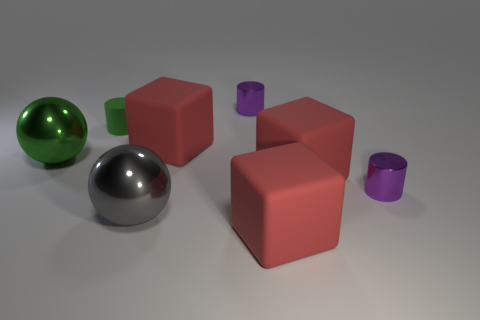Are the green cylinder and the purple cylinder behind the small green cylinder made of the same material?
Provide a short and direct response. No. The small matte thing is what color?
Provide a succinct answer. Green. What is the size of the green ball that is made of the same material as the gray ball?
Provide a short and direct response. Large. There is a big thing behind the green metallic object on the left side of the rubber cylinder; what number of red blocks are in front of it?
Provide a short and direct response. 2. There is a small matte cylinder; is its color the same as the rubber block that is in front of the gray shiny sphere?
Your answer should be very brief. No. What shape is the object that is the same color as the matte cylinder?
Provide a short and direct response. Sphere. What material is the gray sphere that is left of the metal object that is right of the small purple metal object behind the small green rubber cylinder?
Provide a succinct answer. Metal. Is the shape of the red matte object in front of the large gray metallic sphere the same as  the large green shiny thing?
Provide a succinct answer. No. There is a gray ball right of the small green thing; what material is it?
Your answer should be very brief. Metal. What number of shiny objects are large gray things or large green objects?
Offer a terse response. 2. 